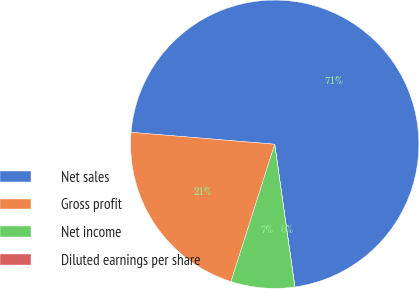Convert chart to OTSL. <chart><loc_0><loc_0><loc_500><loc_500><pie_chart><fcel>Net sales<fcel>Gross profit<fcel>Net income<fcel>Diluted earnings per share<nl><fcel>71.44%<fcel>21.41%<fcel>7.14%<fcel>0.0%<nl></chart> 